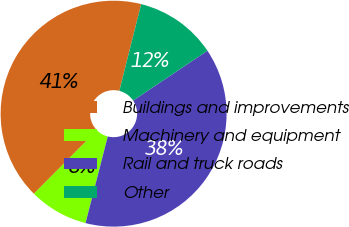<chart> <loc_0><loc_0><loc_500><loc_500><pie_chart><fcel>Buildings and improvements<fcel>Machinery and equipment<fcel>Rail and truck roads<fcel>Other<nl><fcel>41.46%<fcel>8.47%<fcel>38.4%<fcel>11.67%<nl></chart> 